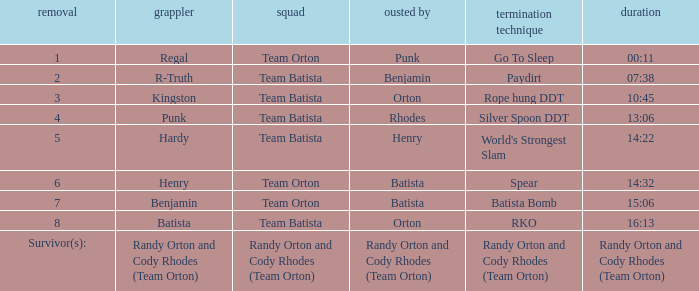What time was the Wrestler Henry eliminated by Batista? 14:32. 